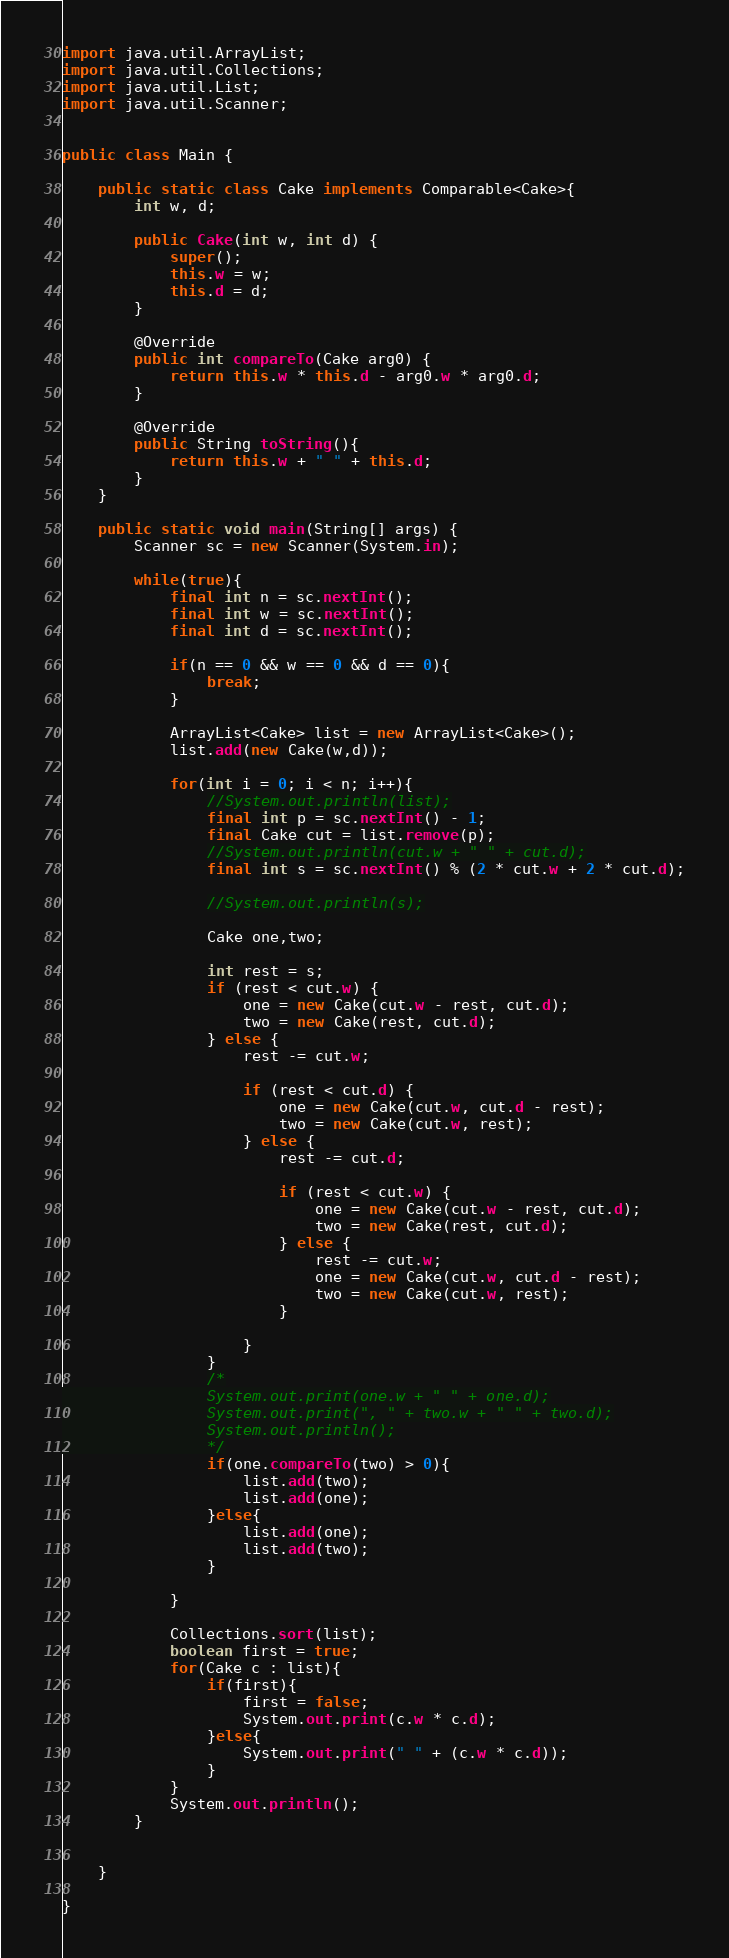<code> <loc_0><loc_0><loc_500><loc_500><_Java_>
import java.util.ArrayList;
import java.util.Collections;
import java.util.List;
import java.util.Scanner;


public class Main {
	
	public static class Cake implements Comparable<Cake>{
		int w, d;

		public Cake(int w, int d) {
			super();
			this.w = w;
			this.d = d;
		}

		@Override
		public int compareTo(Cake arg0) {
			return this.w * this.d - arg0.w * arg0.d;
		}
		
		@Override
		public String toString(){
			return this.w + " " + this.d;
		}
	}
	
	public static void main(String[] args) {
		Scanner sc = new Scanner(System.in);
		
		while(true){
			final int n = sc.nextInt();
			final int w = sc.nextInt();
			final int d = sc.nextInt();
			
			if(n == 0 && w == 0 && d == 0){
				break;
			}
			
			ArrayList<Cake> list = new ArrayList<Cake>();
			list.add(new Cake(w,d));
			
			for(int i = 0; i < n; i++){
				//System.out.println(list);
				final int p = sc.nextInt() - 1;
				final Cake cut = list.remove(p);
				//System.out.println(cut.w + " " + cut.d);
				final int s = sc.nextInt() % (2 * cut.w + 2 * cut.d);

				//System.out.println(s);
				
				Cake one,two;
				
				int rest = s;
				if (rest < cut.w) {
					one = new Cake(cut.w - rest, cut.d);
					two = new Cake(rest, cut.d);
				} else {
					rest -= cut.w;

					if (rest < cut.d) {
						one = new Cake(cut.w, cut.d - rest);
						two = new Cake(cut.w, rest);
					} else {
						rest -= cut.d;

						if (rest < cut.w) {
							one = new Cake(cut.w - rest, cut.d);
							two = new Cake(rest, cut.d);
						} else {
							rest -= cut.w;
							one = new Cake(cut.w, cut.d - rest);
							two = new Cake(cut.w, rest);
						}

					}
				}
				/*
				System.out.print(one.w + " " + one.d);
				System.out.print(", " + two.w + " " + two.d);
				System.out.println();
				*/
				if(one.compareTo(two) > 0){
					list.add(two);
					list.add(one);
				}else{
					list.add(one);
					list.add(two);
				}
				
			}
			
			Collections.sort(list);
			boolean first = true;
			for(Cake c : list){
				if(first){
					first = false;
					System.out.print(c.w * c.d);
				}else{
					System.out.print(" " + (c.w * c.d));
				}
			}
			System.out.println();
		}
		
		
	}

}</code> 